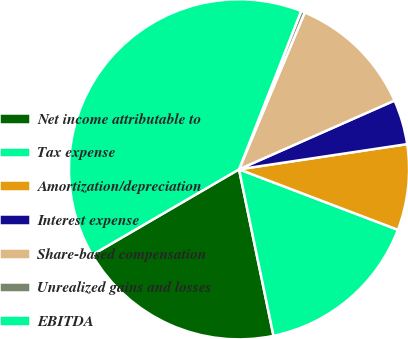Convert chart to OTSL. <chart><loc_0><loc_0><loc_500><loc_500><pie_chart><fcel>Net income attributable to<fcel>Tax expense<fcel>Amortization/depreciation<fcel>Interest expense<fcel>Share-based compensation<fcel>Unrealized gains and losses<fcel>EBITDA<nl><fcel>19.86%<fcel>15.96%<fcel>8.16%<fcel>4.26%<fcel>12.06%<fcel>0.36%<fcel>39.35%<nl></chart> 